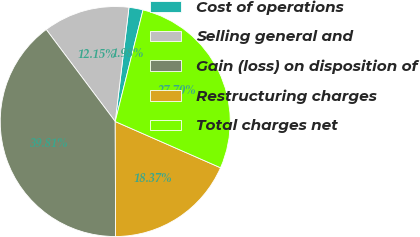Convert chart. <chart><loc_0><loc_0><loc_500><loc_500><pie_chart><fcel>Cost of operations<fcel>Selling general and<fcel>Gain (loss) on disposition of<fcel>Restructuring charges<fcel>Total charges net<nl><fcel>1.98%<fcel>12.15%<fcel>39.81%<fcel>18.37%<fcel>27.7%<nl></chart> 